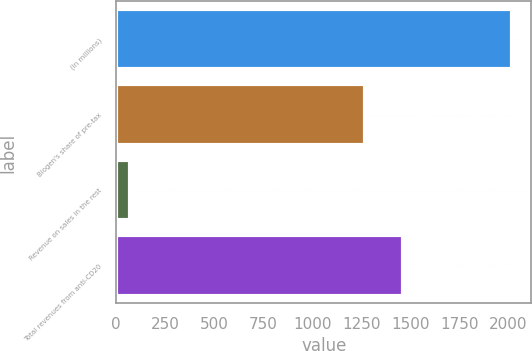Convert chart to OTSL. <chart><loc_0><loc_0><loc_500><loc_500><bar_chart><fcel>(In millions)<fcel>Biogen's share of pre-tax<fcel>Revenue on sales in the rest<fcel>Total revenues from anti-CD20<nl><fcel>2015<fcel>1269.8<fcel>69.4<fcel>1464.36<nl></chart> 